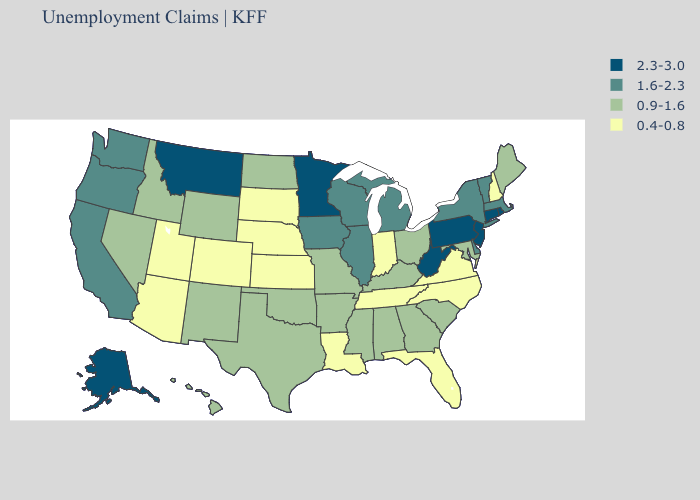What is the value of Alaska?
Keep it brief. 2.3-3.0. Name the states that have a value in the range 0.9-1.6?
Keep it brief. Alabama, Arkansas, Georgia, Hawaii, Idaho, Kentucky, Maine, Maryland, Mississippi, Missouri, Nevada, New Mexico, North Dakota, Ohio, Oklahoma, South Carolina, Texas, Wyoming. Does Nevada have the highest value in the West?
Write a very short answer. No. What is the value of Maryland?
Answer briefly. 0.9-1.6. What is the lowest value in states that border Florida?
Quick response, please. 0.9-1.6. What is the value of Oregon?
Keep it brief. 1.6-2.3. Does North Dakota have a higher value than Virginia?
Keep it brief. Yes. What is the highest value in states that border New Jersey?
Short answer required. 2.3-3.0. Among the states that border Illinois , which have the highest value?
Be succinct. Iowa, Wisconsin. How many symbols are there in the legend?
Give a very brief answer. 4. What is the value of Vermont?
Short answer required. 1.6-2.3. What is the value of Idaho?
Quick response, please. 0.9-1.6. What is the value of Indiana?
Short answer required. 0.4-0.8. Which states have the lowest value in the South?
Answer briefly. Florida, Louisiana, North Carolina, Tennessee, Virginia. Name the states that have a value in the range 2.3-3.0?
Give a very brief answer. Alaska, Connecticut, Minnesota, Montana, New Jersey, Pennsylvania, Rhode Island, West Virginia. 